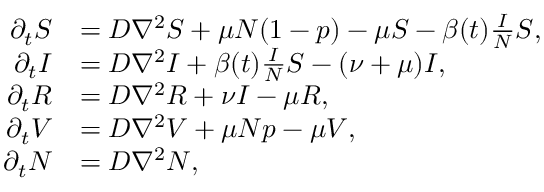<formula> <loc_0><loc_0><loc_500><loc_500>\begin{array} { r l } { \partial _ { t } S } & { = D \nabla ^ { 2 } S + \mu N ( 1 - p ) - \mu S - \beta ( t ) \frac { I } { N } S , } \\ { \partial _ { t } I } & { = D \nabla ^ { 2 } I + \beta ( t ) \frac { I } { N } S - ( \nu + \mu ) I , } \\ { \partial _ { t } R } & { = D \nabla ^ { 2 } R + \nu I - \mu R , } \\ { \partial _ { t } V } & { = D \nabla ^ { 2 } V + \mu N p - \mu V , } \\ { \partial _ { t } N } & { = D \nabla ^ { 2 } N , } \end{array}</formula> 